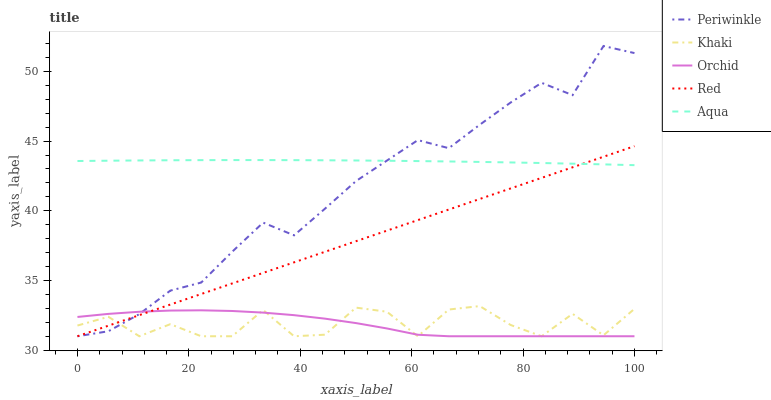Does Orchid have the minimum area under the curve?
Answer yes or no. Yes. Does Aqua have the maximum area under the curve?
Answer yes or no. Yes. Does Khaki have the minimum area under the curve?
Answer yes or no. No. Does Khaki have the maximum area under the curve?
Answer yes or no. No. Is Red the smoothest?
Answer yes or no. Yes. Is Khaki the roughest?
Answer yes or no. Yes. Is Periwinkle the smoothest?
Answer yes or no. No. Is Periwinkle the roughest?
Answer yes or no. No. Does Khaki have the lowest value?
Answer yes or no. Yes. Does Periwinkle have the highest value?
Answer yes or no. Yes. Does Khaki have the highest value?
Answer yes or no. No. Is Khaki less than Aqua?
Answer yes or no. Yes. Is Aqua greater than Khaki?
Answer yes or no. Yes. Does Orchid intersect Khaki?
Answer yes or no. Yes. Is Orchid less than Khaki?
Answer yes or no. No. Is Orchid greater than Khaki?
Answer yes or no. No. Does Khaki intersect Aqua?
Answer yes or no. No. 